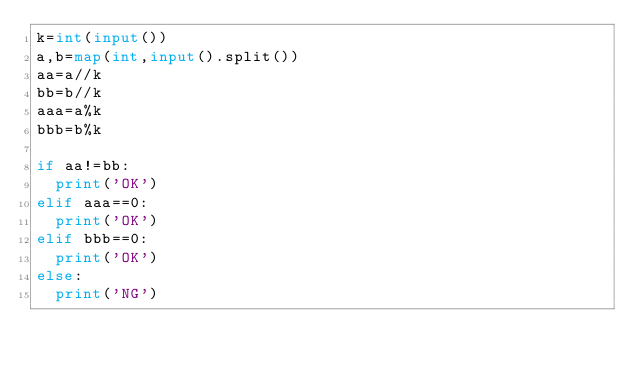Convert code to text. <code><loc_0><loc_0><loc_500><loc_500><_Python_>k=int(input())
a,b=map(int,input().split())
aa=a//k
bb=b//k
aaa=a%k
bbb=b%k

if aa!=bb:
  print('OK')
elif aaa==0:
  print('OK')
elif bbb==0:
  print('OK')
else:
  print('NG')
      </code> 